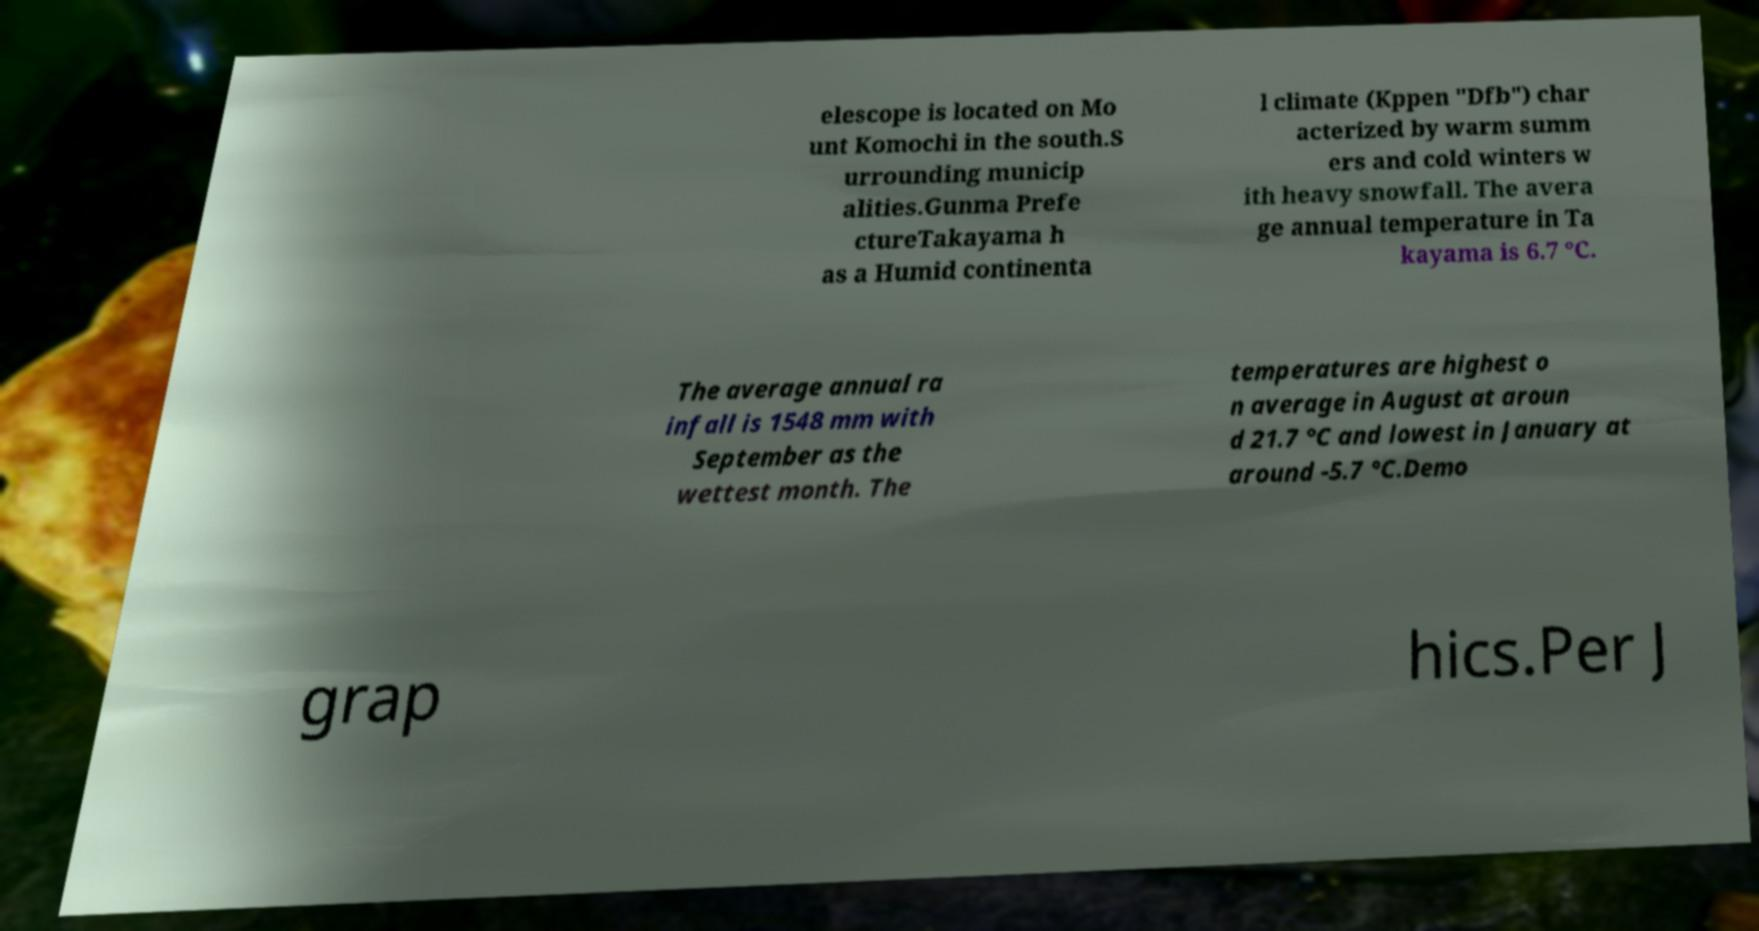Please identify and transcribe the text found in this image. elescope is located on Mo unt Komochi in the south.S urrounding municip alities.Gunma Prefe ctureTakayama h as a Humid continenta l climate (Kppen "Dfb") char acterized by warm summ ers and cold winters w ith heavy snowfall. The avera ge annual temperature in Ta kayama is 6.7 °C. The average annual ra infall is 1548 mm with September as the wettest month. The temperatures are highest o n average in August at aroun d 21.7 °C and lowest in January at around -5.7 °C.Demo grap hics.Per J 